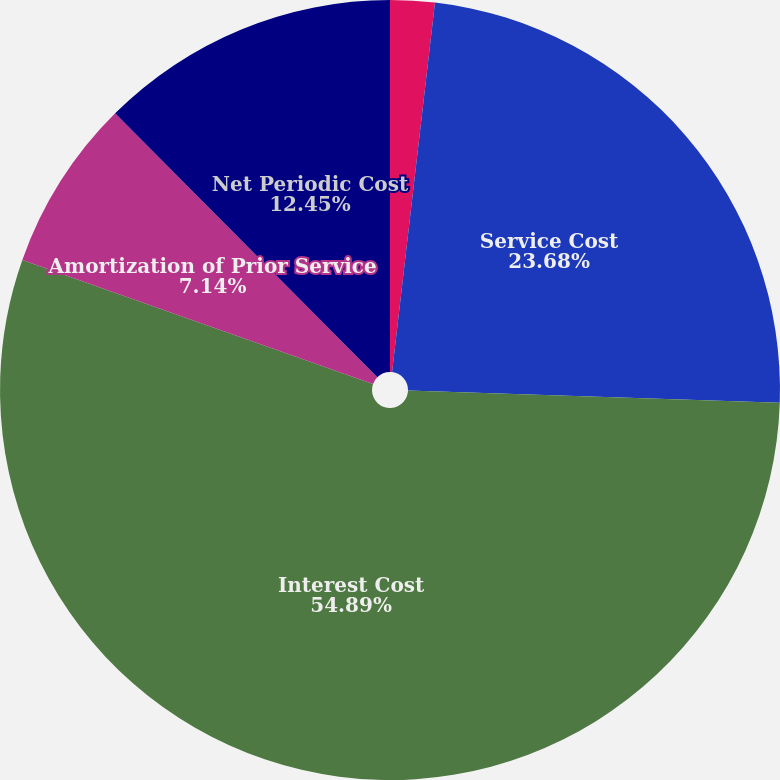Convert chart. <chart><loc_0><loc_0><loc_500><loc_500><pie_chart><fcel>(in thousands)<fcel>Service Cost<fcel>Interest Cost<fcel>Amortization of Prior Service<fcel>Net Periodic Cost<nl><fcel>1.84%<fcel>23.68%<fcel>54.9%<fcel>7.14%<fcel>12.45%<nl></chart> 